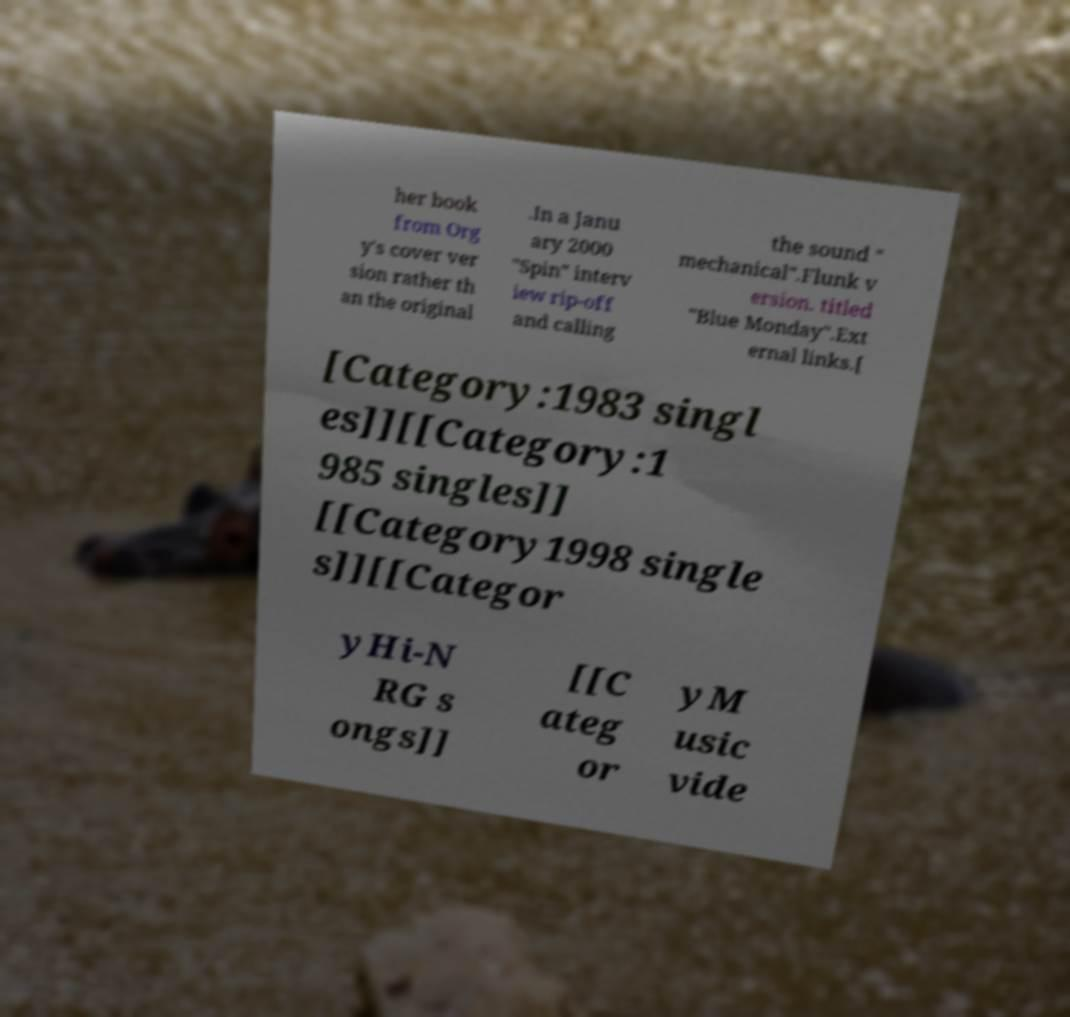Please read and relay the text visible in this image. What does it say? her book from Org y's cover ver sion rather th an the original .In a Janu ary 2000 "Spin" interv iew rip-off and calling the sound " mechanical".Flunk v ersion. titled "Blue Monday".Ext ernal links.[ [Category:1983 singl es]][[Category:1 985 singles]] [[Category1998 single s]][[Categor yHi-N RG s ongs]] [[C ateg or yM usic vide 